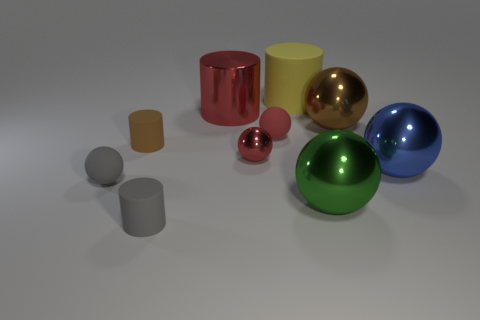Subtract all blue balls. How many balls are left? 5 Subtract all tiny red rubber spheres. How many spheres are left? 5 Subtract all brown spheres. Subtract all cyan cylinders. How many spheres are left? 5 Subtract all cylinders. How many objects are left? 6 Add 5 red matte balls. How many red matte balls are left? 6 Add 2 tiny yellow rubber blocks. How many tiny yellow rubber blocks exist? 2 Subtract 0 gray blocks. How many objects are left? 10 Subtract all tiny red metallic balls. Subtract all green spheres. How many objects are left? 8 